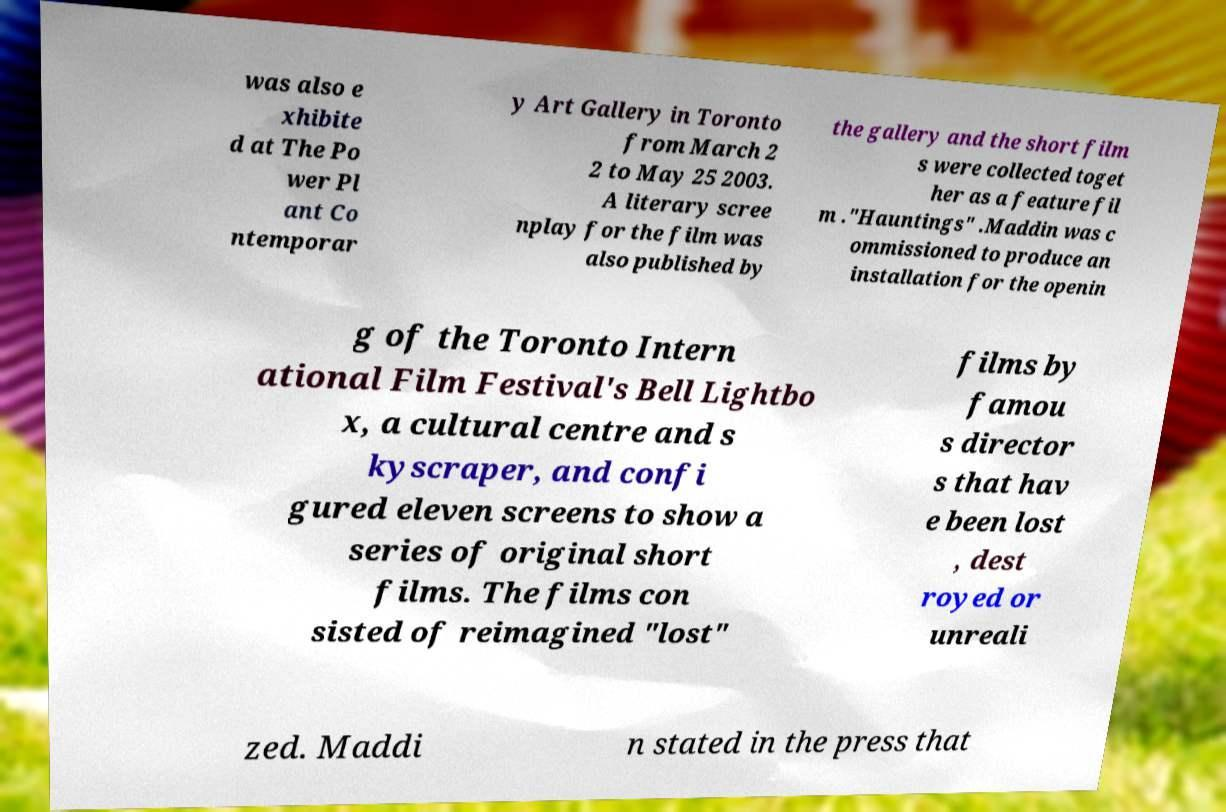Please read and relay the text visible in this image. What does it say? was also e xhibite d at The Po wer Pl ant Co ntemporar y Art Gallery in Toronto from March 2 2 to May 25 2003. A literary scree nplay for the film was also published by the gallery and the short film s were collected toget her as a feature fil m ."Hauntings" .Maddin was c ommissioned to produce an installation for the openin g of the Toronto Intern ational Film Festival's Bell Lightbo x, a cultural centre and s kyscraper, and confi gured eleven screens to show a series of original short films. The films con sisted of reimagined "lost" films by famou s director s that hav e been lost , dest royed or unreali zed. Maddi n stated in the press that 